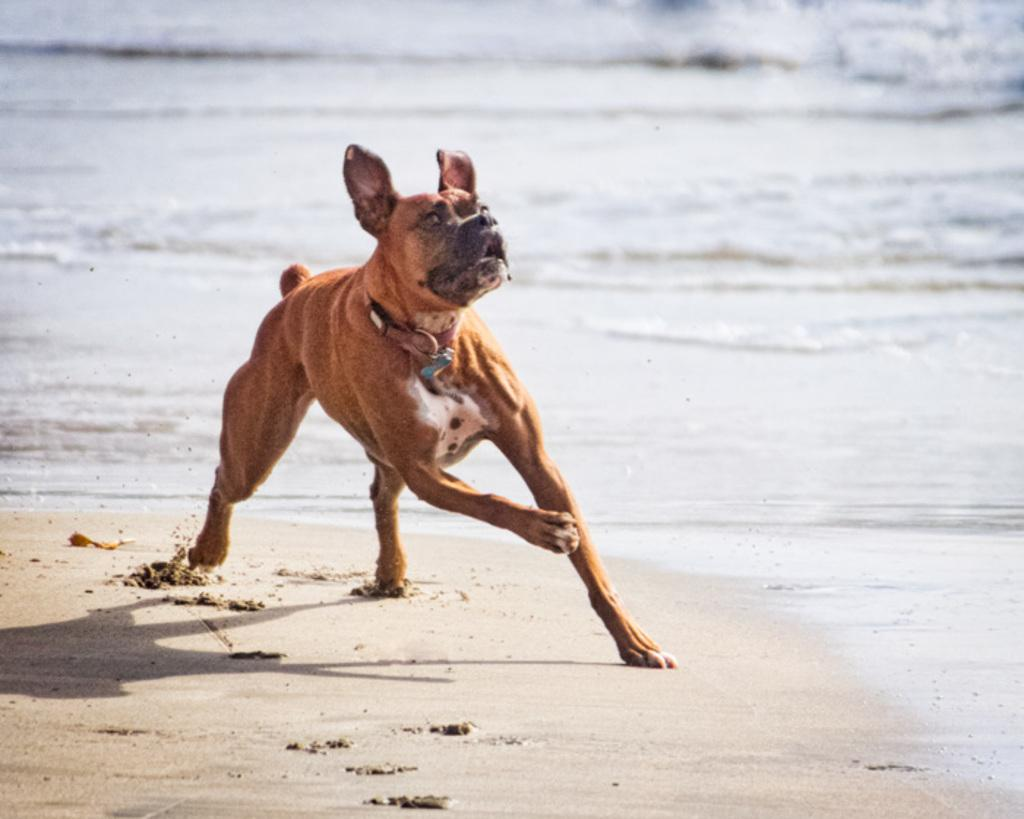What type of terrain is near the sea in the image? There is sand near the sea in the image. What is the dog in the image doing? The dog is running on the sand. Can you describe the water visible in the image? There is water visible in the image. What type of skate is the dog using to run on the sand? There is no skate present in the image; the dog is running on the sand without any skate. What color is the pencil used to draw the water in the image? There is no pencil present in the image; the water is depicted as it naturally appears. 